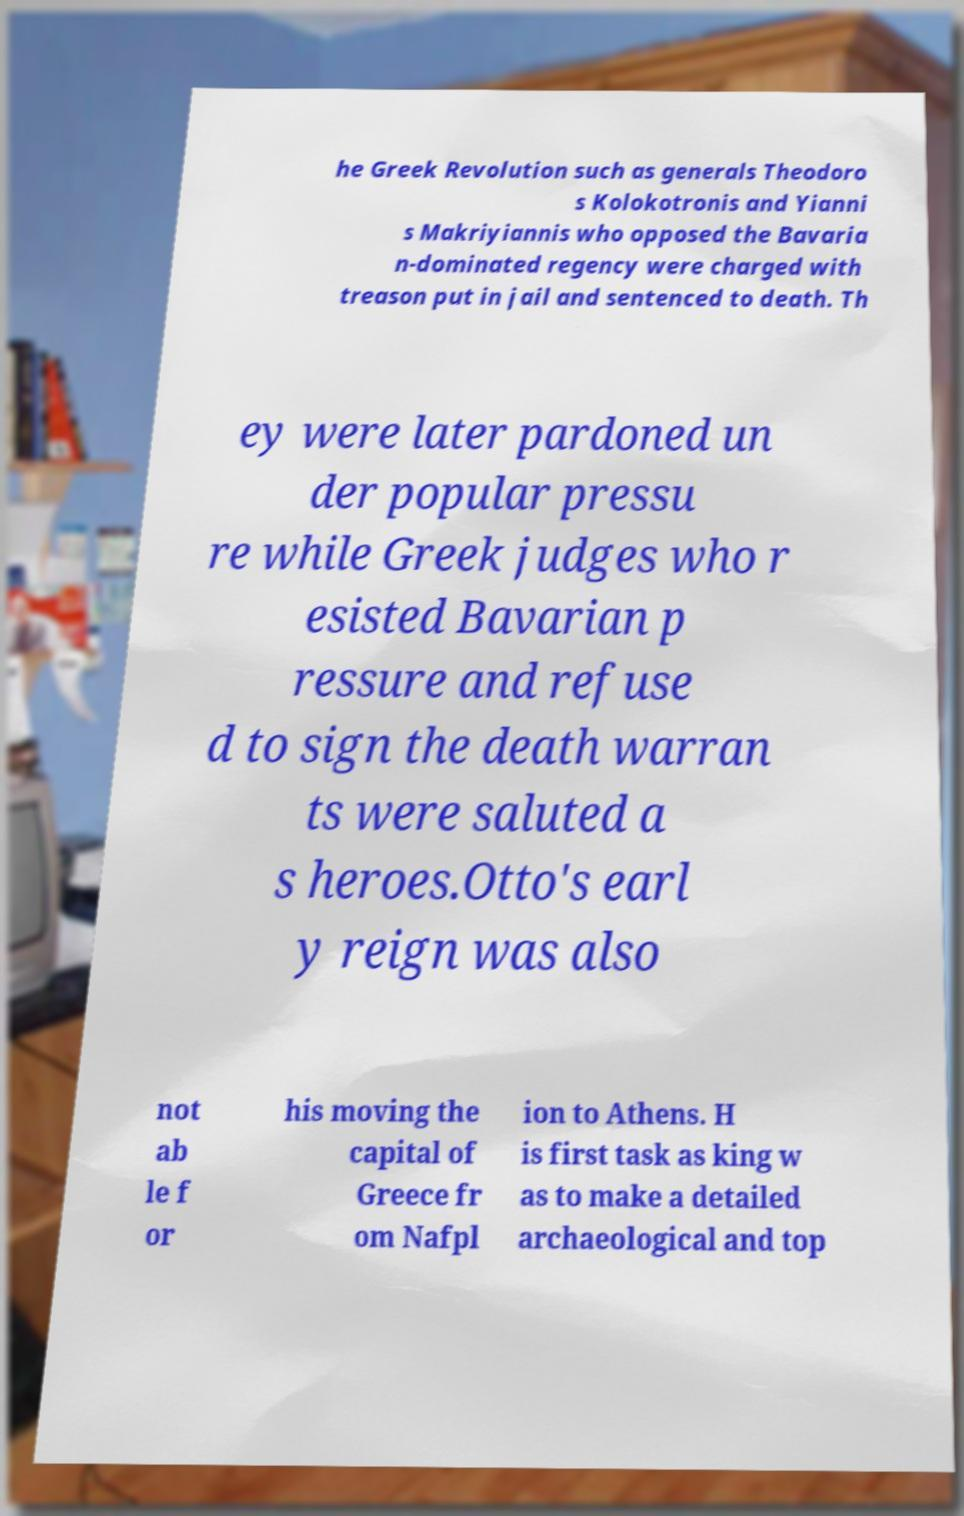I need the written content from this picture converted into text. Can you do that? he Greek Revolution such as generals Theodoro s Kolokotronis and Yianni s Makriyiannis who opposed the Bavaria n-dominated regency were charged with treason put in jail and sentenced to death. Th ey were later pardoned un der popular pressu re while Greek judges who r esisted Bavarian p ressure and refuse d to sign the death warran ts were saluted a s heroes.Otto's earl y reign was also not ab le f or his moving the capital of Greece fr om Nafpl ion to Athens. H is first task as king w as to make a detailed archaeological and top 